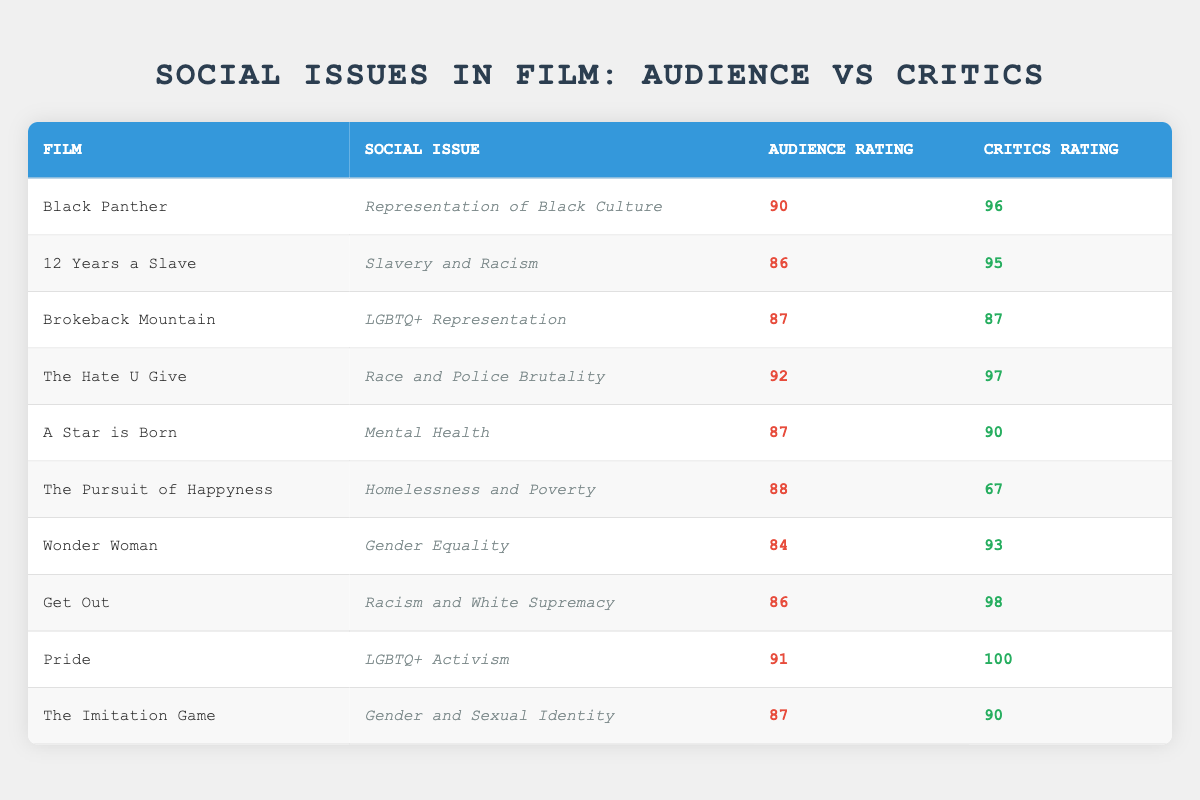What is the audience rating for "Black Panther"? The table lists "Black Panther" under the Film column with an audience rating entry of 90.
Answer: 90 Which film has the highest audience rating? Looking at the audience ratings in the table, "The Hate U Give" has the highest rating of 92.
Answer: 92 Is the audience rating for "Pride" greater than 90? The audience rating for "Pride" is 91, which is greater than 90.
Answer: Yes What is the average audience rating of the films that address LGBTQ+ issues? The films addressing LGBTQ+ issues are "Brokeback Mountain" (87), "Pride" (91), and "The Imitation Game" (87). Adding these ratings gives 87 + 91 + 87 = 265, and dividing by 3 results in an average of 265 / 3 = 88.33.
Answer: 88.33 Is there a film that has a higher critics rating than its audience rating? Yes, "The Pursuit of Happyness" has a critics rating of 67 while its audience rating is 88.
Answer: Yes What is the difference between the audience rating and critics rating for "Get Out"? "Get Out" has an audience rating of 86 and a critics rating of 98. The difference is 98 - 86 = 12.
Answer: 12 What percentage of films in the table address themes related to race? The films that address race are "Black Panther," "12 Years a Slave," "The Hate U Give," and "Get Out," which totals 4 out of 10 films. Calculating the percentage gives (4/10) * 100% = 40%.
Answer: 40% Which social issue in films received the lowest audience rating? "Wonder Woman" with a social issue of "Gender Equality" received the lowest audience rating of 84, making it the issue with the lowest rating.
Answer: 84 How many films address mental health, and what is their average audience rating? Only "A Star is Born" addresses mental health, with an audience rating of 87. The average for one film is simply 87.
Answer: 87 